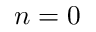Convert formula to latex. <formula><loc_0><loc_0><loc_500><loc_500>n = 0</formula> 